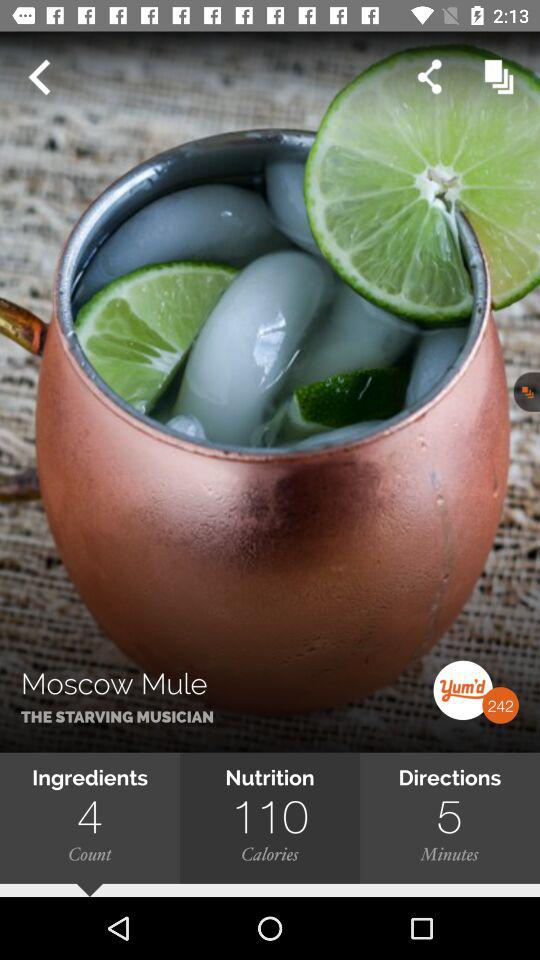How many calories of nutrition are there in "Moscow Mule"? There are 110 calories of nutrition in "Moscow Mule". 